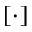Convert formula to latex. <formula><loc_0><loc_0><loc_500><loc_500>[ \cdot ]</formula> 